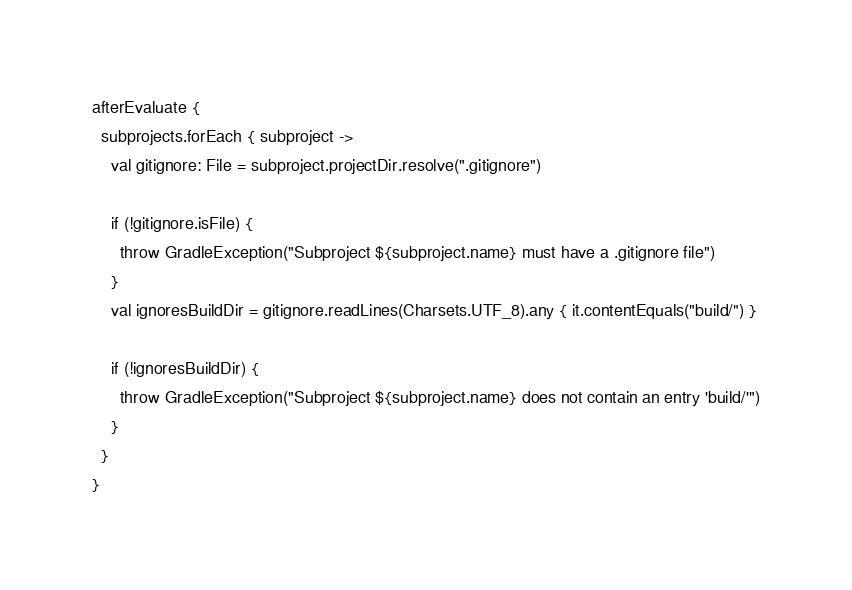Convert code to text. <code><loc_0><loc_0><loc_500><loc_500><_Kotlin_>afterEvaluate {
  subprojects.forEach { subproject ->
    val gitignore: File = subproject.projectDir.resolve(".gitignore")

    if (!gitignore.isFile) {
      throw GradleException("Subproject ${subproject.name} must have a .gitignore file")
    }
    val ignoresBuildDir = gitignore.readLines(Charsets.UTF_8).any { it.contentEquals("build/") }

    if (!ignoresBuildDir) {
      throw GradleException("Subproject ${subproject.name} does not contain an entry 'build/'")
    }
  }
}
</code> 